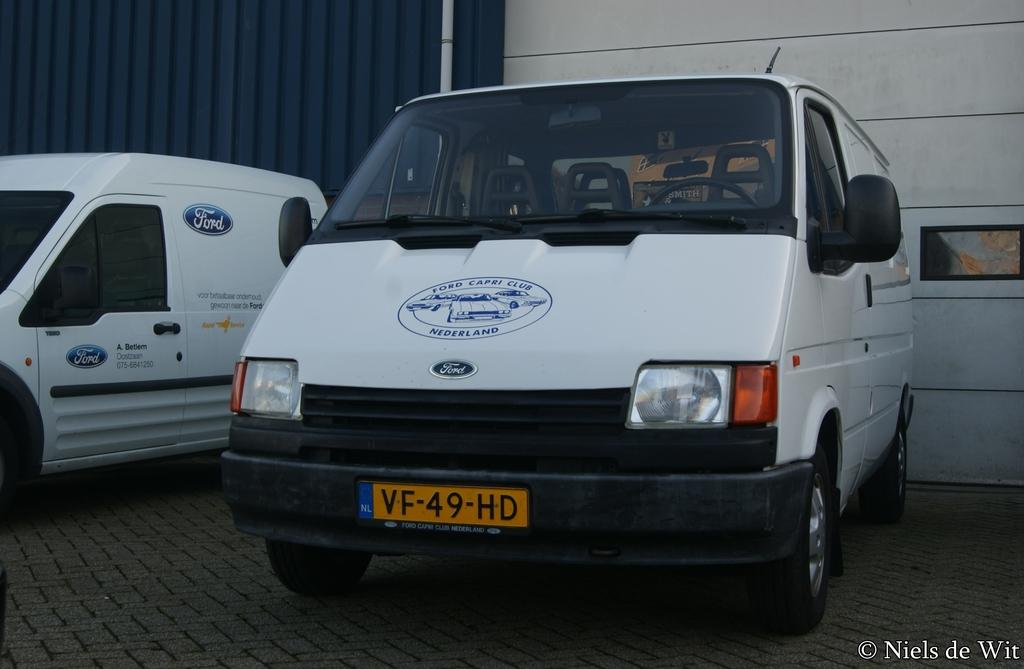What is the license plate of this van?
Provide a succinct answer. Vf-49-hd. What is the car manufacturer?
Ensure brevity in your answer.  Ford. 